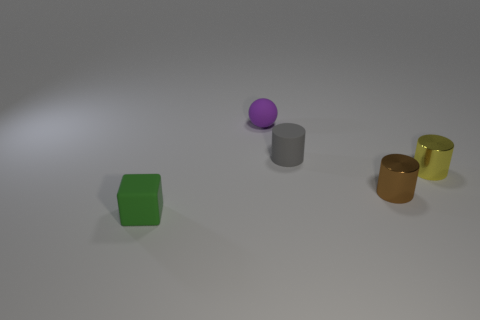There is a small brown shiny thing that is on the right side of the sphere; is its shape the same as the tiny gray object?
Your answer should be compact. Yes. Is the number of small cylinders in front of the tiny purple sphere greater than the number of big cylinders?
Keep it short and to the point. Yes. What color is the matte thing in front of the tiny metal object that is to the left of the tiny yellow metallic cylinder?
Provide a succinct answer. Green. How many tiny gray rubber spheres are there?
Keep it short and to the point. 0. What number of tiny rubber things are both on the left side of the tiny gray cylinder and right of the tiny green matte block?
Your response must be concise. 1. Is there anything else that is the same shape as the small purple object?
Make the answer very short. No. There is a small green rubber thing to the left of the tiny gray rubber cylinder; what is its shape?
Your answer should be compact. Cube. How many other things are the same material as the purple object?
Your answer should be compact. 2. What is the yellow cylinder made of?
Your response must be concise. Metal. What number of tiny objects are either yellow metallic cylinders or metallic things?
Your response must be concise. 2. 